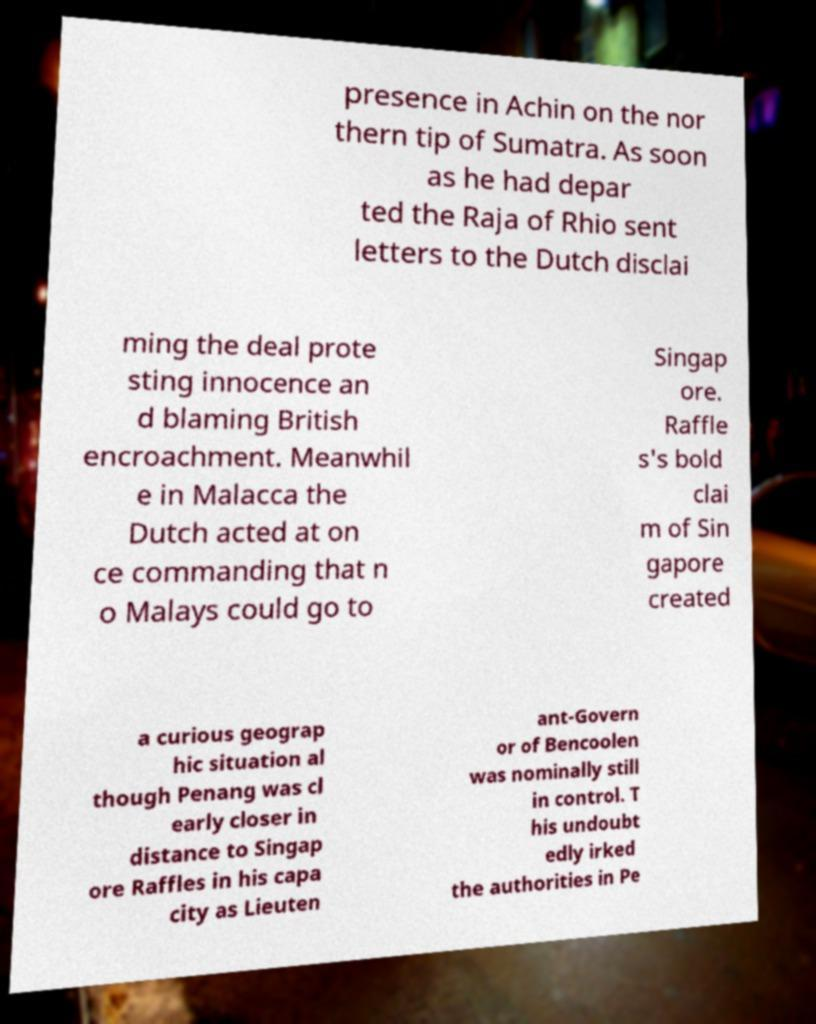Could you assist in decoding the text presented in this image and type it out clearly? presence in Achin on the nor thern tip of Sumatra. As soon as he had depar ted the Raja of Rhio sent letters to the Dutch disclai ming the deal prote sting innocence an d blaming British encroachment. Meanwhil e in Malacca the Dutch acted at on ce commanding that n o Malays could go to Singap ore. Raffle s's bold clai m of Sin gapore created a curious geograp hic situation al though Penang was cl early closer in distance to Singap ore Raffles in his capa city as Lieuten ant-Govern or of Bencoolen was nominally still in control. T his undoubt edly irked the authorities in Pe 